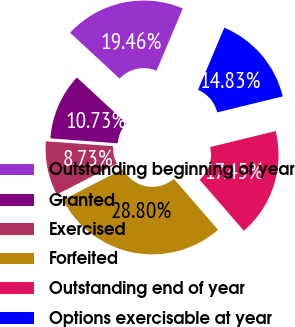Convert chart to OTSL. <chart><loc_0><loc_0><loc_500><loc_500><pie_chart><fcel>Outstanding beginning of year<fcel>Granted<fcel>Exercised<fcel>Forfeited<fcel>Outstanding end of year<fcel>Options exercisable at year<nl><fcel>19.46%<fcel>10.73%<fcel>8.73%<fcel>28.8%<fcel>17.45%<fcel>14.83%<nl></chart> 